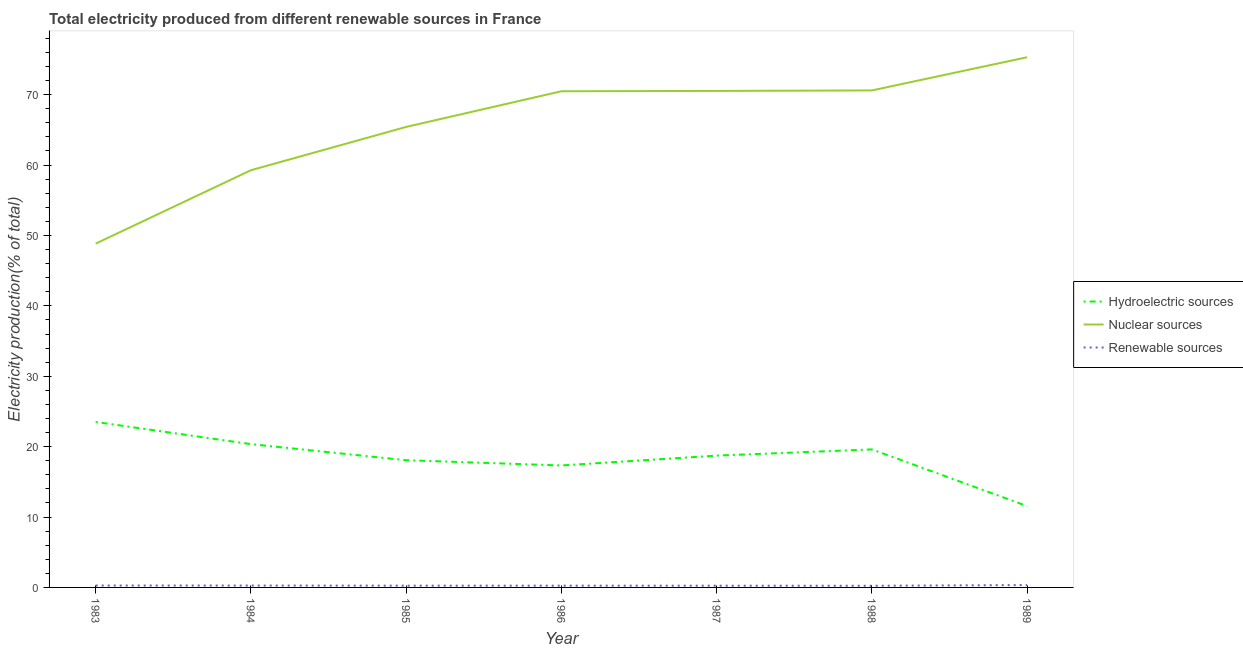How many different coloured lines are there?
Your answer should be compact. 3. Does the line corresponding to percentage of electricity produced by nuclear sources intersect with the line corresponding to percentage of electricity produced by renewable sources?
Keep it short and to the point. No. What is the percentage of electricity produced by hydroelectric sources in 1984?
Your answer should be very brief. 20.36. Across all years, what is the maximum percentage of electricity produced by hydroelectric sources?
Provide a short and direct response. 23.51. Across all years, what is the minimum percentage of electricity produced by hydroelectric sources?
Provide a succinct answer. 11.56. In which year was the percentage of electricity produced by nuclear sources maximum?
Give a very brief answer. 1989. What is the total percentage of electricity produced by renewable sources in the graph?
Offer a very short reply. 1.86. What is the difference between the percentage of electricity produced by renewable sources in 1983 and that in 1989?
Provide a short and direct response. -0.07. What is the difference between the percentage of electricity produced by renewable sources in 1983 and the percentage of electricity produced by hydroelectric sources in 1989?
Provide a short and direct response. -11.29. What is the average percentage of electricity produced by nuclear sources per year?
Give a very brief answer. 65.78. In the year 1986, what is the difference between the percentage of electricity produced by renewable sources and percentage of electricity produced by nuclear sources?
Offer a very short reply. -70.24. What is the ratio of the percentage of electricity produced by nuclear sources in 1986 to that in 1988?
Make the answer very short. 1. Is the percentage of electricity produced by hydroelectric sources in 1986 less than that in 1988?
Offer a very short reply. Yes. What is the difference between the highest and the second highest percentage of electricity produced by hydroelectric sources?
Your answer should be very brief. 3.15. What is the difference between the highest and the lowest percentage of electricity produced by renewable sources?
Make the answer very short. 0.1. In how many years, is the percentage of electricity produced by nuclear sources greater than the average percentage of electricity produced by nuclear sources taken over all years?
Offer a terse response. 4. Is it the case that in every year, the sum of the percentage of electricity produced by hydroelectric sources and percentage of electricity produced by nuclear sources is greater than the percentage of electricity produced by renewable sources?
Your response must be concise. Yes. Does the percentage of electricity produced by nuclear sources monotonically increase over the years?
Your answer should be compact. Yes. What is the difference between two consecutive major ticks on the Y-axis?
Offer a very short reply. 10. Does the graph contain any zero values?
Your answer should be compact. No. Does the graph contain grids?
Provide a succinct answer. No. How are the legend labels stacked?
Make the answer very short. Vertical. What is the title of the graph?
Your response must be concise. Total electricity produced from different renewable sources in France. Does "Textiles and clothing" appear as one of the legend labels in the graph?
Your response must be concise. No. What is the Electricity production(% of total) in Hydroelectric sources in 1983?
Provide a succinct answer. 23.51. What is the Electricity production(% of total) of Nuclear sources in 1983?
Provide a succinct answer. 48.84. What is the Electricity production(% of total) of Renewable sources in 1983?
Your response must be concise. 0.27. What is the Electricity production(% of total) in Hydroelectric sources in 1984?
Your answer should be very brief. 20.36. What is the Electricity production(% of total) of Nuclear sources in 1984?
Offer a terse response. 59.27. What is the Electricity production(% of total) in Renewable sources in 1984?
Make the answer very short. 0.27. What is the Electricity production(% of total) in Hydroelectric sources in 1985?
Give a very brief answer. 18.07. What is the Electricity production(% of total) of Nuclear sources in 1985?
Keep it short and to the point. 65.42. What is the Electricity production(% of total) in Renewable sources in 1985?
Provide a succinct answer. 0.25. What is the Electricity production(% of total) of Hydroelectric sources in 1986?
Offer a very short reply. 17.33. What is the Electricity production(% of total) in Nuclear sources in 1986?
Give a very brief answer. 70.49. What is the Electricity production(% of total) of Renewable sources in 1986?
Provide a short and direct response. 0.25. What is the Electricity production(% of total) of Hydroelectric sources in 1987?
Ensure brevity in your answer.  18.73. What is the Electricity production(% of total) in Nuclear sources in 1987?
Provide a succinct answer. 70.53. What is the Electricity production(% of total) of Renewable sources in 1987?
Provide a short and direct response. 0.25. What is the Electricity production(% of total) in Hydroelectric sources in 1988?
Keep it short and to the point. 19.61. What is the Electricity production(% of total) in Nuclear sources in 1988?
Give a very brief answer. 70.6. What is the Electricity production(% of total) in Renewable sources in 1988?
Your response must be concise. 0.24. What is the Electricity production(% of total) in Hydroelectric sources in 1989?
Offer a very short reply. 11.56. What is the Electricity production(% of total) in Nuclear sources in 1989?
Your response must be concise. 75.32. What is the Electricity production(% of total) of Renewable sources in 1989?
Your answer should be compact. 0.34. Across all years, what is the maximum Electricity production(% of total) in Hydroelectric sources?
Offer a very short reply. 23.51. Across all years, what is the maximum Electricity production(% of total) in Nuclear sources?
Provide a succinct answer. 75.32. Across all years, what is the maximum Electricity production(% of total) in Renewable sources?
Your response must be concise. 0.34. Across all years, what is the minimum Electricity production(% of total) of Hydroelectric sources?
Make the answer very short. 11.56. Across all years, what is the minimum Electricity production(% of total) of Nuclear sources?
Offer a very short reply. 48.84. Across all years, what is the minimum Electricity production(% of total) in Renewable sources?
Ensure brevity in your answer.  0.24. What is the total Electricity production(% of total) of Hydroelectric sources in the graph?
Make the answer very short. 129.16. What is the total Electricity production(% of total) in Nuclear sources in the graph?
Your answer should be compact. 460.47. What is the total Electricity production(% of total) of Renewable sources in the graph?
Offer a very short reply. 1.86. What is the difference between the Electricity production(% of total) of Hydroelectric sources in 1983 and that in 1984?
Offer a terse response. 3.15. What is the difference between the Electricity production(% of total) of Nuclear sources in 1983 and that in 1984?
Keep it short and to the point. -10.43. What is the difference between the Electricity production(% of total) in Renewable sources in 1983 and that in 1984?
Provide a short and direct response. 0. What is the difference between the Electricity production(% of total) of Hydroelectric sources in 1983 and that in 1985?
Give a very brief answer. 5.43. What is the difference between the Electricity production(% of total) in Nuclear sources in 1983 and that in 1985?
Your answer should be very brief. -16.58. What is the difference between the Electricity production(% of total) in Renewable sources in 1983 and that in 1985?
Give a very brief answer. 0.02. What is the difference between the Electricity production(% of total) of Hydroelectric sources in 1983 and that in 1986?
Give a very brief answer. 6.18. What is the difference between the Electricity production(% of total) of Nuclear sources in 1983 and that in 1986?
Your answer should be compact. -21.64. What is the difference between the Electricity production(% of total) in Renewable sources in 1983 and that in 1986?
Provide a short and direct response. 0.02. What is the difference between the Electricity production(% of total) in Hydroelectric sources in 1983 and that in 1987?
Your response must be concise. 4.78. What is the difference between the Electricity production(% of total) in Nuclear sources in 1983 and that in 1987?
Offer a very short reply. -21.69. What is the difference between the Electricity production(% of total) of Renewable sources in 1983 and that in 1987?
Ensure brevity in your answer.  0.02. What is the difference between the Electricity production(% of total) in Hydroelectric sources in 1983 and that in 1988?
Your answer should be very brief. 3.9. What is the difference between the Electricity production(% of total) of Nuclear sources in 1983 and that in 1988?
Your response must be concise. -21.76. What is the difference between the Electricity production(% of total) of Renewable sources in 1983 and that in 1988?
Ensure brevity in your answer.  0.03. What is the difference between the Electricity production(% of total) in Hydroelectric sources in 1983 and that in 1989?
Provide a succinct answer. 11.95. What is the difference between the Electricity production(% of total) in Nuclear sources in 1983 and that in 1989?
Offer a very short reply. -26.47. What is the difference between the Electricity production(% of total) in Renewable sources in 1983 and that in 1989?
Offer a very short reply. -0.07. What is the difference between the Electricity production(% of total) in Hydroelectric sources in 1984 and that in 1985?
Provide a short and direct response. 2.28. What is the difference between the Electricity production(% of total) of Nuclear sources in 1984 and that in 1985?
Your answer should be compact. -6.15. What is the difference between the Electricity production(% of total) in Renewable sources in 1984 and that in 1985?
Give a very brief answer. 0.02. What is the difference between the Electricity production(% of total) in Hydroelectric sources in 1984 and that in 1986?
Give a very brief answer. 3.03. What is the difference between the Electricity production(% of total) of Nuclear sources in 1984 and that in 1986?
Make the answer very short. -11.22. What is the difference between the Electricity production(% of total) in Renewable sources in 1984 and that in 1986?
Ensure brevity in your answer.  0.02. What is the difference between the Electricity production(% of total) of Hydroelectric sources in 1984 and that in 1987?
Offer a very short reply. 1.63. What is the difference between the Electricity production(% of total) in Nuclear sources in 1984 and that in 1987?
Offer a very short reply. -11.26. What is the difference between the Electricity production(% of total) of Renewable sources in 1984 and that in 1987?
Make the answer very short. 0.02. What is the difference between the Electricity production(% of total) of Hydroelectric sources in 1984 and that in 1988?
Offer a terse response. 0.75. What is the difference between the Electricity production(% of total) in Nuclear sources in 1984 and that in 1988?
Ensure brevity in your answer.  -11.34. What is the difference between the Electricity production(% of total) in Renewable sources in 1984 and that in 1988?
Your answer should be very brief. 0.03. What is the difference between the Electricity production(% of total) in Hydroelectric sources in 1984 and that in 1989?
Give a very brief answer. 8.8. What is the difference between the Electricity production(% of total) in Nuclear sources in 1984 and that in 1989?
Your response must be concise. -16.05. What is the difference between the Electricity production(% of total) in Renewable sources in 1984 and that in 1989?
Your response must be concise. -0.07. What is the difference between the Electricity production(% of total) in Hydroelectric sources in 1985 and that in 1986?
Provide a succinct answer. 0.75. What is the difference between the Electricity production(% of total) in Nuclear sources in 1985 and that in 1986?
Offer a terse response. -5.07. What is the difference between the Electricity production(% of total) of Renewable sources in 1985 and that in 1986?
Offer a terse response. -0. What is the difference between the Electricity production(% of total) in Hydroelectric sources in 1985 and that in 1987?
Give a very brief answer. -0.65. What is the difference between the Electricity production(% of total) of Nuclear sources in 1985 and that in 1987?
Make the answer very short. -5.11. What is the difference between the Electricity production(% of total) in Renewable sources in 1985 and that in 1987?
Keep it short and to the point. 0. What is the difference between the Electricity production(% of total) in Hydroelectric sources in 1985 and that in 1988?
Provide a short and direct response. -1.53. What is the difference between the Electricity production(% of total) in Nuclear sources in 1985 and that in 1988?
Offer a terse response. -5.18. What is the difference between the Electricity production(% of total) of Renewable sources in 1985 and that in 1988?
Your response must be concise. 0.01. What is the difference between the Electricity production(% of total) in Hydroelectric sources in 1985 and that in 1989?
Give a very brief answer. 6.52. What is the difference between the Electricity production(% of total) in Nuclear sources in 1985 and that in 1989?
Provide a succinct answer. -9.9. What is the difference between the Electricity production(% of total) in Renewable sources in 1985 and that in 1989?
Give a very brief answer. -0.08. What is the difference between the Electricity production(% of total) of Hydroelectric sources in 1986 and that in 1987?
Your answer should be compact. -1.4. What is the difference between the Electricity production(% of total) in Nuclear sources in 1986 and that in 1987?
Provide a succinct answer. -0.05. What is the difference between the Electricity production(% of total) of Renewable sources in 1986 and that in 1987?
Give a very brief answer. 0.01. What is the difference between the Electricity production(% of total) of Hydroelectric sources in 1986 and that in 1988?
Provide a short and direct response. -2.28. What is the difference between the Electricity production(% of total) in Nuclear sources in 1986 and that in 1988?
Keep it short and to the point. -0.12. What is the difference between the Electricity production(% of total) in Renewable sources in 1986 and that in 1988?
Ensure brevity in your answer.  0.01. What is the difference between the Electricity production(% of total) of Hydroelectric sources in 1986 and that in 1989?
Ensure brevity in your answer.  5.77. What is the difference between the Electricity production(% of total) in Nuclear sources in 1986 and that in 1989?
Your answer should be very brief. -4.83. What is the difference between the Electricity production(% of total) in Renewable sources in 1986 and that in 1989?
Offer a terse response. -0.08. What is the difference between the Electricity production(% of total) of Hydroelectric sources in 1987 and that in 1988?
Offer a terse response. -0.88. What is the difference between the Electricity production(% of total) in Nuclear sources in 1987 and that in 1988?
Your answer should be very brief. -0.07. What is the difference between the Electricity production(% of total) in Renewable sources in 1987 and that in 1988?
Keep it short and to the point. 0.01. What is the difference between the Electricity production(% of total) of Hydroelectric sources in 1987 and that in 1989?
Make the answer very short. 7.17. What is the difference between the Electricity production(% of total) in Nuclear sources in 1987 and that in 1989?
Ensure brevity in your answer.  -4.78. What is the difference between the Electricity production(% of total) of Renewable sources in 1987 and that in 1989?
Give a very brief answer. -0.09. What is the difference between the Electricity production(% of total) in Hydroelectric sources in 1988 and that in 1989?
Ensure brevity in your answer.  8.05. What is the difference between the Electricity production(% of total) in Nuclear sources in 1988 and that in 1989?
Keep it short and to the point. -4.71. What is the difference between the Electricity production(% of total) in Renewable sources in 1988 and that in 1989?
Your answer should be very brief. -0.1. What is the difference between the Electricity production(% of total) of Hydroelectric sources in 1983 and the Electricity production(% of total) of Nuclear sources in 1984?
Make the answer very short. -35.76. What is the difference between the Electricity production(% of total) of Hydroelectric sources in 1983 and the Electricity production(% of total) of Renewable sources in 1984?
Your answer should be very brief. 23.24. What is the difference between the Electricity production(% of total) in Nuclear sources in 1983 and the Electricity production(% of total) in Renewable sources in 1984?
Offer a very short reply. 48.57. What is the difference between the Electricity production(% of total) of Hydroelectric sources in 1983 and the Electricity production(% of total) of Nuclear sources in 1985?
Offer a terse response. -41.91. What is the difference between the Electricity production(% of total) of Hydroelectric sources in 1983 and the Electricity production(% of total) of Renewable sources in 1985?
Ensure brevity in your answer.  23.26. What is the difference between the Electricity production(% of total) of Nuclear sources in 1983 and the Electricity production(% of total) of Renewable sources in 1985?
Give a very brief answer. 48.59. What is the difference between the Electricity production(% of total) in Hydroelectric sources in 1983 and the Electricity production(% of total) in Nuclear sources in 1986?
Offer a terse response. -46.98. What is the difference between the Electricity production(% of total) in Hydroelectric sources in 1983 and the Electricity production(% of total) in Renewable sources in 1986?
Offer a very short reply. 23.26. What is the difference between the Electricity production(% of total) in Nuclear sources in 1983 and the Electricity production(% of total) in Renewable sources in 1986?
Your answer should be compact. 48.59. What is the difference between the Electricity production(% of total) of Hydroelectric sources in 1983 and the Electricity production(% of total) of Nuclear sources in 1987?
Your answer should be very brief. -47.03. What is the difference between the Electricity production(% of total) in Hydroelectric sources in 1983 and the Electricity production(% of total) in Renewable sources in 1987?
Make the answer very short. 23.26. What is the difference between the Electricity production(% of total) of Nuclear sources in 1983 and the Electricity production(% of total) of Renewable sources in 1987?
Make the answer very short. 48.6. What is the difference between the Electricity production(% of total) of Hydroelectric sources in 1983 and the Electricity production(% of total) of Nuclear sources in 1988?
Ensure brevity in your answer.  -47.1. What is the difference between the Electricity production(% of total) of Hydroelectric sources in 1983 and the Electricity production(% of total) of Renewable sources in 1988?
Keep it short and to the point. 23.27. What is the difference between the Electricity production(% of total) in Nuclear sources in 1983 and the Electricity production(% of total) in Renewable sources in 1988?
Give a very brief answer. 48.61. What is the difference between the Electricity production(% of total) in Hydroelectric sources in 1983 and the Electricity production(% of total) in Nuclear sources in 1989?
Keep it short and to the point. -51.81. What is the difference between the Electricity production(% of total) of Hydroelectric sources in 1983 and the Electricity production(% of total) of Renewable sources in 1989?
Ensure brevity in your answer.  23.17. What is the difference between the Electricity production(% of total) in Nuclear sources in 1983 and the Electricity production(% of total) in Renewable sources in 1989?
Provide a succinct answer. 48.51. What is the difference between the Electricity production(% of total) of Hydroelectric sources in 1984 and the Electricity production(% of total) of Nuclear sources in 1985?
Your answer should be compact. -45.06. What is the difference between the Electricity production(% of total) in Hydroelectric sources in 1984 and the Electricity production(% of total) in Renewable sources in 1985?
Provide a succinct answer. 20.11. What is the difference between the Electricity production(% of total) of Nuclear sources in 1984 and the Electricity production(% of total) of Renewable sources in 1985?
Offer a very short reply. 59.02. What is the difference between the Electricity production(% of total) in Hydroelectric sources in 1984 and the Electricity production(% of total) in Nuclear sources in 1986?
Your answer should be very brief. -50.13. What is the difference between the Electricity production(% of total) in Hydroelectric sources in 1984 and the Electricity production(% of total) in Renewable sources in 1986?
Ensure brevity in your answer.  20.11. What is the difference between the Electricity production(% of total) in Nuclear sources in 1984 and the Electricity production(% of total) in Renewable sources in 1986?
Provide a short and direct response. 59.02. What is the difference between the Electricity production(% of total) of Hydroelectric sources in 1984 and the Electricity production(% of total) of Nuclear sources in 1987?
Keep it short and to the point. -50.18. What is the difference between the Electricity production(% of total) of Hydroelectric sources in 1984 and the Electricity production(% of total) of Renewable sources in 1987?
Provide a succinct answer. 20.11. What is the difference between the Electricity production(% of total) in Nuclear sources in 1984 and the Electricity production(% of total) in Renewable sources in 1987?
Provide a short and direct response. 59.02. What is the difference between the Electricity production(% of total) in Hydroelectric sources in 1984 and the Electricity production(% of total) in Nuclear sources in 1988?
Provide a short and direct response. -50.25. What is the difference between the Electricity production(% of total) in Hydroelectric sources in 1984 and the Electricity production(% of total) in Renewable sources in 1988?
Your answer should be very brief. 20.12. What is the difference between the Electricity production(% of total) in Nuclear sources in 1984 and the Electricity production(% of total) in Renewable sources in 1988?
Your response must be concise. 59.03. What is the difference between the Electricity production(% of total) of Hydroelectric sources in 1984 and the Electricity production(% of total) of Nuclear sources in 1989?
Your answer should be very brief. -54.96. What is the difference between the Electricity production(% of total) of Hydroelectric sources in 1984 and the Electricity production(% of total) of Renewable sources in 1989?
Offer a very short reply. 20.02. What is the difference between the Electricity production(% of total) of Nuclear sources in 1984 and the Electricity production(% of total) of Renewable sources in 1989?
Offer a very short reply. 58.93. What is the difference between the Electricity production(% of total) of Hydroelectric sources in 1985 and the Electricity production(% of total) of Nuclear sources in 1986?
Your response must be concise. -52.41. What is the difference between the Electricity production(% of total) in Hydroelectric sources in 1985 and the Electricity production(% of total) in Renewable sources in 1986?
Ensure brevity in your answer.  17.82. What is the difference between the Electricity production(% of total) of Nuclear sources in 1985 and the Electricity production(% of total) of Renewable sources in 1986?
Make the answer very short. 65.17. What is the difference between the Electricity production(% of total) in Hydroelectric sources in 1985 and the Electricity production(% of total) in Nuclear sources in 1987?
Give a very brief answer. -52.46. What is the difference between the Electricity production(% of total) in Hydroelectric sources in 1985 and the Electricity production(% of total) in Renewable sources in 1987?
Offer a terse response. 17.83. What is the difference between the Electricity production(% of total) of Nuclear sources in 1985 and the Electricity production(% of total) of Renewable sources in 1987?
Your answer should be very brief. 65.17. What is the difference between the Electricity production(% of total) of Hydroelectric sources in 1985 and the Electricity production(% of total) of Nuclear sources in 1988?
Offer a very short reply. -52.53. What is the difference between the Electricity production(% of total) in Hydroelectric sources in 1985 and the Electricity production(% of total) in Renewable sources in 1988?
Provide a succinct answer. 17.84. What is the difference between the Electricity production(% of total) in Nuclear sources in 1985 and the Electricity production(% of total) in Renewable sources in 1988?
Provide a succinct answer. 65.18. What is the difference between the Electricity production(% of total) of Hydroelectric sources in 1985 and the Electricity production(% of total) of Nuclear sources in 1989?
Your response must be concise. -57.24. What is the difference between the Electricity production(% of total) in Hydroelectric sources in 1985 and the Electricity production(% of total) in Renewable sources in 1989?
Your answer should be very brief. 17.74. What is the difference between the Electricity production(% of total) in Nuclear sources in 1985 and the Electricity production(% of total) in Renewable sources in 1989?
Keep it short and to the point. 65.09. What is the difference between the Electricity production(% of total) in Hydroelectric sources in 1986 and the Electricity production(% of total) in Nuclear sources in 1987?
Provide a short and direct response. -53.21. What is the difference between the Electricity production(% of total) of Hydroelectric sources in 1986 and the Electricity production(% of total) of Renewable sources in 1987?
Keep it short and to the point. 17.08. What is the difference between the Electricity production(% of total) of Nuclear sources in 1986 and the Electricity production(% of total) of Renewable sources in 1987?
Ensure brevity in your answer.  70.24. What is the difference between the Electricity production(% of total) of Hydroelectric sources in 1986 and the Electricity production(% of total) of Nuclear sources in 1988?
Make the answer very short. -53.28. What is the difference between the Electricity production(% of total) in Hydroelectric sources in 1986 and the Electricity production(% of total) in Renewable sources in 1988?
Your answer should be very brief. 17.09. What is the difference between the Electricity production(% of total) of Nuclear sources in 1986 and the Electricity production(% of total) of Renewable sources in 1988?
Keep it short and to the point. 70.25. What is the difference between the Electricity production(% of total) in Hydroelectric sources in 1986 and the Electricity production(% of total) in Nuclear sources in 1989?
Ensure brevity in your answer.  -57.99. What is the difference between the Electricity production(% of total) in Hydroelectric sources in 1986 and the Electricity production(% of total) in Renewable sources in 1989?
Make the answer very short. 16.99. What is the difference between the Electricity production(% of total) of Nuclear sources in 1986 and the Electricity production(% of total) of Renewable sources in 1989?
Your answer should be very brief. 70.15. What is the difference between the Electricity production(% of total) of Hydroelectric sources in 1987 and the Electricity production(% of total) of Nuclear sources in 1988?
Provide a short and direct response. -51.88. What is the difference between the Electricity production(% of total) of Hydroelectric sources in 1987 and the Electricity production(% of total) of Renewable sources in 1988?
Provide a short and direct response. 18.49. What is the difference between the Electricity production(% of total) of Nuclear sources in 1987 and the Electricity production(% of total) of Renewable sources in 1988?
Ensure brevity in your answer.  70.3. What is the difference between the Electricity production(% of total) of Hydroelectric sources in 1987 and the Electricity production(% of total) of Nuclear sources in 1989?
Your answer should be compact. -56.59. What is the difference between the Electricity production(% of total) in Hydroelectric sources in 1987 and the Electricity production(% of total) in Renewable sources in 1989?
Make the answer very short. 18.39. What is the difference between the Electricity production(% of total) in Nuclear sources in 1987 and the Electricity production(% of total) in Renewable sources in 1989?
Provide a succinct answer. 70.2. What is the difference between the Electricity production(% of total) in Hydroelectric sources in 1988 and the Electricity production(% of total) in Nuclear sources in 1989?
Your response must be concise. -55.71. What is the difference between the Electricity production(% of total) in Hydroelectric sources in 1988 and the Electricity production(% of total) in Renewable sources in 1989?
Your answer should be compact. 19.27. What is the difference between the Electricity production(% of total) of Nuclear sources in 1988 and the Electricity production(% of total) of Renewable sources in 1989?
Offer a very short reply. 70.27. What is the average Electricity production(% of total) in Hydroelectric sources per year?
Your answer should be very brief. 18.45. What is the average Electricity production(% of total) in Nuclear sources per year?
Provide a succinct answer. 65.78. What is the average Electricity production(% of total) of Renewable sources per year?
Give a very brief answer. 0.27. In the year 1983, what is the difference between the Electricity production(% of total) in Hydroelectric sources and Electricity production(% of total) in Nuclear sources?
Offer a terse response. -25.33. In the year 1983, what is the difference between the Electricity production(% of total) in Hydroelectric sources and Electricity production(% of total) in Renewable sources?
Offer a terse response. 23.24. In the year 1983, what is the difference between the Electricity production(% of total) of Nuclear sources and Electricity production(% of total) of Renewable sources?
Keep it short and to the point. 48.57. In the year 1984, what is the difference between the Electricity production(% of total) in Hydroelectric sources and Electricity production(% of total) in Nuclear sources?
Ensure brevity in your answer.  -38.91. In the year 1984, what is the difference between the Electricity production(% of total) of Hydroelectric sources and Electricity production(% of total) of Renewable sources?
Keep it short and to the point. 20.09. In the year 1984, what is the difference between the Electricity production(% of total) in Nuclear sources and Electricity production(% of total) in Renewable sources?
Make the answer very short. 59. In the year 1985, what is the difference between the Electricity production(% of total) of Hydroelectric sources and Electricity production(% of total) of Nuclear sources?
Your answer should be very brief. -47.35. In the year 1985, what is the difference between the Electricity production(% of total) of Hydroelectric sources and Electricity production(% of total) of Renewable sources?
Offer a terse response. 17.82. In the year 1985, what is the difference between the Electricity production(% of total) in Nuclear sources and Electricity production(% of total) in Renewable sources?
Make the answer very short. 65.17. In the year 1986, what is the difference between the Electricity production(% of total) of Hydroelectric sources and Electricity production(% of total) of Nuclear sources?
Offer a very short reply. -53.16. In the year 1986, what is the difference between the Electricity production(% of total) of Hydroelectric sources and Electricity production(% of total) of Renewable sources?
Offer a terse response. 17.08. In the year 1986, what is the difference between the Electricity production(% of total) of Nuclear sources and Electricity production(% of total) of Renewable sources?
Offer a very short reply. 70.24. In the year 1987, what is the difference between the Electricity production(% of total) in Hydroelectric sources and Electricity production(% of total) in Nuclear sources?
Make the answer very short. -51.81. In the year 1987, what is the difference between the Electricity production(% of total) of Hydroelectric sources and Electricity production(% of total) of Renewable sources?
Provide a succinct answer. 18.48. In the year 1987, what is the difference between the Electricity production(% of total) of Nuclear sources and Electricity production(% of total) of Renewable sources?
Keep it short and to the point. 70.29. In the year 1988, what is the difference between the Electricity production(% of total) in Hydroelectric sources and Electricity production(% of total) in Nuclear sources?
Offer a very short reply. -50.99. In the year 1988, what is the difference between the Electricity production(% of total) in Hydroelectric sources and Electricity production(% of total) in Renewable sources?
Your answer should be very brief. 19.37. In the year 1988, what is the difference between the Electricity production(% of total) of Nuclear sources and Electricity production(% of total) of Renewable sources?
Offer a terse response. 70.37. In the year 1989, what is the difference between the Electricity production(% of total) of Hydroelectric sources and Electricity production(% of total) of Nuclear sources?
Give a very brief answer. -63.76. In the year 1989, what is the difference between the Electricity production(% of total) in Hydroelectric sources and Electricity production(% of total) in Renewable sources?
Provide a succinct answer. 11.22. In the year 1989, what is the difference between the Electricity production(% of total) of Nuclear sources and Electricity production(% of total) of Renewable sources?
Ensure brevity in your answer.  74.98. What is the ratio of the Electricity production(% of total) in Hydroelectric sources in 1983 to that in 1984?
Offer a very short reply. 1.15. What is the ratio of the Electricity production(% of total) of Nuclear sources in 1983 to that in 1984?
Give a very brief answer. 0.82. What is the ratio of the Electricity production(% of total) in Renewable sources in 1983 to that in 1984?
Offer a terse response. 1.01. What is the ratio of the Electricity production(% of total) in Hydroelectric sources in 1983 to that in 1985?
Give a very brief answer. 1.3. What is the ratio of the Electricity production(% of total) in Nuclear sources in 1983 to that in 1985?
Your response must be concise. 0.75. What is the ratio of the Electricity production(% of total) in Renewable sources in 1983 to that in 1985?
Provide a short and direct response. 1.08. What is the ratio of the Electricity production(% of total) of Hydroelectric sources in 1983 to that in 1986?
Keep it short and to the point. 1.36. What is the ratio of the Electricity production(% of total) of Nuclear sources in 1983 to that in 1986?
Your response must be concise. 0.69. What is the ratio of the Electricity production(% of total) in Renewable sources in 1983 to that in 1986?
Your answer should be compact. 1.07. What is the ratio of the Electricity production(% of total) of Hydroelectric sources in 1983 to that in 1987?
Your answer should be very brief. 1.26. What is the ratio of the Electricity production(% of total) of Nuclear sources in 1983 to that in 1987?
Provide a short and direct response. 0.69. What is the ratio of the Electricity production(% of total) of Renewable sources in 1983 to that in 1987?
Provide a short and direct response. 1.1. What is the ratio of the Electricity production(% of total) of Hydroelectric sources in 1983 to that in 1988?
Make the answer very short. 1.2. What is the ratio of the Electricity production(% of total) of Nuclear sources in 1983 to that in 1988?
Your answer should be very brief. 0.69. What is the ratio of the Electricity production(% of total) in Renewable sources in 1983 to that in 1988?
Ensure brevity in your answer.  1.14. What is the ratio of the Electricity production(% of total) of Hydroelectric sources in 1983 to that in 1989?
Make the answer very short. 2.03. What is the ratio of the Electricity production(% of total) of Nuclear sources in 1983 to that in 1989?
Offer a very short reply. 0.65. What is the ratio of the Electricity production(% of total) of Renewable sources in 1983 to that in 1989?
Your answer should be compact. 0.8. What is the ratio of the Electricity production(% of total) in Hydroelectric sources in 1984 to that in 1985?
Provide a short and direct response. 1.13. What is the ratio of the Electricity production(% of total) of Nuclear sources in 1984 to that in 1985?
Keep it short and to the point. 0.91. What is the ratio of the Electricity production(% of total) in Renewable sources in 1984 to that in 1985?
Provide a short and direct response. 1.07. What is the ratio of the Electricity production(% of total) in Hydroelectric sources in 1984 to that in 1986?
Provide a succinct answer. 1.17. What is the ratio of the Electricity production(% of total) of Nuclear sources in 1984 to that in 1986?
Make the answer very short. 0.84. What is the ratio of the Electricity production(% of total) of Renewable sources in 1984 to that in 1986?
Make the answer very short. 1.07. What is the ratio of the Electricity production(% of total) in Hydroelectric sources in 1984 to that in 1987?
Offer a very short reply. 1.09. What is the ratio of the Electricity production(% of total) in Nuclear sources in 1984 to that in 1987?
Offer a terse response. 0.84. What is the ratio of the Electricity production(% of total) of Renewable sources in 1984 to that in 1987?
Offer a very short reply. 1.09. What is the ratio of the Electricity production(% of total) of Hydroelectric sources in 1984 to that in 1988?
Your answer should be very brief. 1.04. What is the ratio of the Electricity production(% of total) of Nuclear sources in 1984 to that in 1988?
Keep it short and to the point. 0.84. What is the ratio of the Electricity production(% of total) of Renewable sources in 1984 to that in 1988?
Provide a succinct answer. 1.13. What is the ratio of the Electricity production(% of total) of Hydroelectric sources in 1984 to that in 1989?
Provide a succinct answer. 1.76. What is the ratio of the Electricity production(% of total) of Nuclear sources in 1984 to that in 1989?
Give a very brief answer. 0.79. What is the ratio of the Electricity production(% of total) of Renewable sources in 1984 to that in 1989?
Provide a short and direct response. 0.8. What is the ratio of the Electricity production(% of total) in Hydroelectric sources in 1985 to that in 1986?
Your answer should be compact. 1.04. What is the ratio of the Electricity production(% of total) of Nuclear sources in 1985 to that in 1986?
Give a very brief answer. 0.93. What is the ratio of the Electricity production(% of total) in Hydroelectric sources in 1985 to that in 1987?
Make the answer very short. 0.97. What is the ratio of the Electricity production(% of total) in Nuclear sources in 1985 to that in 1987?
Your response must be concise. 0.93. What is the ratio of the Electricity production(% of total) of Renewable sources in 1985 to that in 1987?
Provide a succinct answer. 1.02. What is the ratio of the Electricity production(% of total) in Hydroelectric sources in 1985 to that in 1988?
Give a very brief answer. 0.92. What is the ratio of the Electricity production(% of total) in Nuclear sources in 1985 to that in 1988?
Your answer should be compact. 0.93. What is the ratio of the Electricity production(% of total) in Renewable sources in 1985 to that in 1988?
Make the answer very short. 1.06. What is the ratio of the Electricity production(% of total) of Hydroelectric sources in 1985 to that in 1989?
Offer a terse response. 1.56. What is the ratio of the Electricity production(% of total) in Nuclear sources in 1985 to that in 1989?
Ensure brevity in your answer.  0.87. What is the ratio of the Electricity production(% of total) of Renewable sources in 1985 to that in 1989?
Keep it short and to the point. 0.75. What is the ratio of the Electricity production(% of total) in Hydroelectric sources in 1986 to that in 1987?
Your response must be concise. 0.93. What is the ratio of the Electricity production(% of total) in Renewable sources in 1986 to that in 1987?
Your response must be concise. 1.02. What is the ratio of the Electricity production(% of total) in Hydroelectric sources in 1986 to that in 1988?
Make the answer very short. 0.88. What is the ratio of the Electricity production(% of total) of Nuclear sources in 1986 to that in 1988?
Give a very brief answer. 1. What is the ratio of the Electricity production(% of total) in Renewable sources in 1986 to that in 1988?
Offer a terse response. 1.06. What is the ratio of the Electricity production(% of total) in Hydroelectric sources in 1986 to that in 1989?
Keep it short and to the point. 1.5. What is the ratio of the Electricity production(% of total) of Nuclear sources in 1986 to that in 1989?
Provide a short and direct response. 0.94. What is the ratio of the Electricity production(% of total) of Renewable sources in 1986 to that in 1989?
Make the answer very short. 0.75. What is the ratio of the Electricity production(% of total) in Hydroelectric sources in 1987 to that in 1988?
Provide a succinct answer. 0.95. What is the ratio of the Electricity production(% of total) in Renewable sources in 1987 to that in 1988?
Make the answer very short. 1.04. What is the ratio of the Electricity production(% of total) in Hydroelectric sources in 1987 to that in 1989?
Offer a terse response. 1.62. What is the ratio of the Electricity production(% of total) in Nuclear sources in 1987 to that in 1989?
Ensure brevity in your answer.  0.94. What is the ratio of the Electricity production(% of total) of Renewable sources in 1987 to that in 1989?
Offer a very short reply. 0.73. What is the ratio of the Electricity production(% of total) of Hydroelectric sources in 1988 to that in 1989?
Give a very brief answer. 1.7. What is the ratio of the Electricity production(% of total) in Nuclear sources in 1988 to that in 1989?
Your response must be concise. 0.94. What is the ratio of the Electricity production(% of total) of Renewable sources in 1988 to that in 1989?
Make the answer very short. 0.71. What is the difference between the highest and the second highest Electricity production(% of total) of Hydroelectric sources?
Your response must be concise. 3.15. What is the difference between the highest and the second highest Electricity production(% of total) of Nuclear sources?
Your answer should be compact. 4.71. What is the difference between the highest and the second highest Electricity production(% of total) of Renewable sources?
Your response must be concise. 0.07. What is the difference between the highest and the lowest Electricity production(% of total) of Hydroelectric sources?
Your response must be concise. 11.95. What is the difference between the highest and the lowest Electricity production(% of total) of Nuclear sources?
Keep it short and to the point. 26.47. What is the difference between the highest and the lowest Electricity production(% of total) in Renewable sources?
Keep it short and to the point. 0.1. 